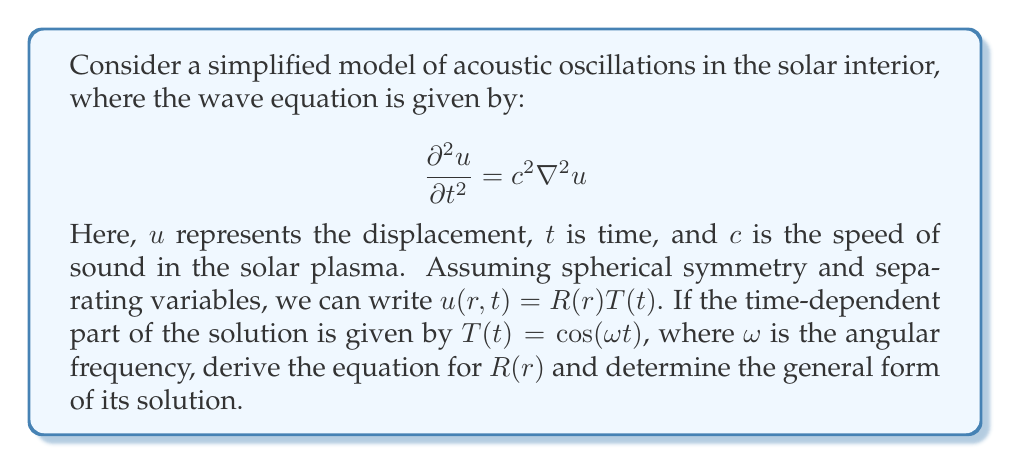Can you answer this question? Let's approach this step-by-step:

1) We start with the wave equation in spherical coordinates, assuming spherical symmetry:

   $$\frac{\partial^2 u}{\partial t^2} = c^2 \left(\frac{\partial^2 u}{\partial r^2} + \frac{2}{r}\frac{\partial u}{\partial r}\right)$$

2) We substitute $u(r,t) = R(r)T(t)$ into this equation:

   $$R(r)\frac{d^2T}{dt^2} = c^2 \left(T(t)\frac{d^2R}{dr^2} + \frac{2}{r}T(t)\frac{dR}{dr}\right)$$

3) We're given that $T(t) = \cos(\omega t)$, so $\frac{d^2T}{dt^2} = -\omega^2 \cos(\omega t) = -\omega^2 T(t)$

4) Substituting this into our equation:

   $$-\omega^2 R(r)T(t) = c^2 \left(T(t)\frac{d^2R}{dr^2} + \frac{2}{r}T(t)\frac{dR}{dr}\right)$$

5) The $T(t)$ cancels out on both sides:

   $$-\omega^2 R(r) = c^2 \left(\frac{d^2R}{dr^2} + \frac{2}{r}\frac{dR}{dr}\right)$$

6) Rearranging:

   $$\frac{d^2R}{dr^2} + \frac{2}{r}\frac{dR}{dr} + \frac{\omega^2}{c^2}R = 0$$

7) This is the equation for $R(r)$. It's a form of the spherical Bessel equation. The general solution is:

   $$R(r) = \frac{A}{r}\sin\left(\frac{\omega r}{c}\right) + \frac{B}{r}\cos\left(\frac{\omega r}{c}\right)$$

   where $A$ and $B$ are constants determined by boundary conditions.
Answer: $R(r) = \frac{A}{r}\sin\left(\frac{\omega r}{c}\right) + \frac{B}{r}\cos\left(\frac{\omega r}{c}\right)$ 